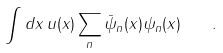Convert formula to latex. <formula><loc_0><loc_0><loc_500><loc_500>\int d { x } \, u ( { x } ) \sum _ { n } { \bar { \psi } } _ { n } ( { x } ) \psi _ { n } ( { x } ) \quad .</formula> 